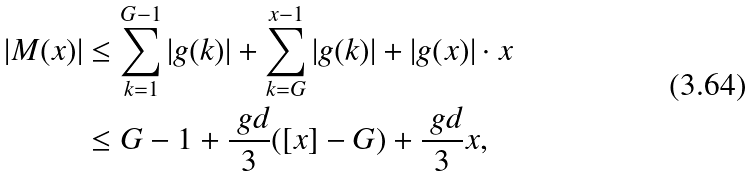<formula> <loc_0><loc_0><loc_500><loc_500>| M ( x ) | & \leq \sum _ { k = 1 } ^ { G - 1 } | g ( k ) | + \sum _ { k = G } ^ { x - 1 } | g ( k ) | + | g ( x ) | \cdot x \\ & \leq G - 1 + \frac { \ g d } { 3 } ( [ x ] - G ) + \frac { \ g d } { 3 } x ,</formula> 